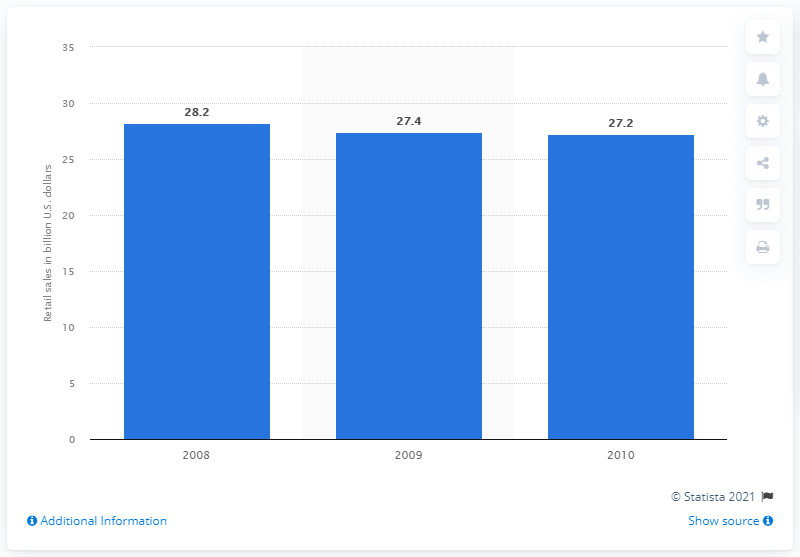Highlight a few significant elements in this photo. In 2008, the retail sales amount of U.S. department stores was 28.2 billion dollars. 